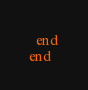Convert code to text. <code><loc_0><loc_0><loc_500><loc_500><_Ruby_>  end
end
</code> 